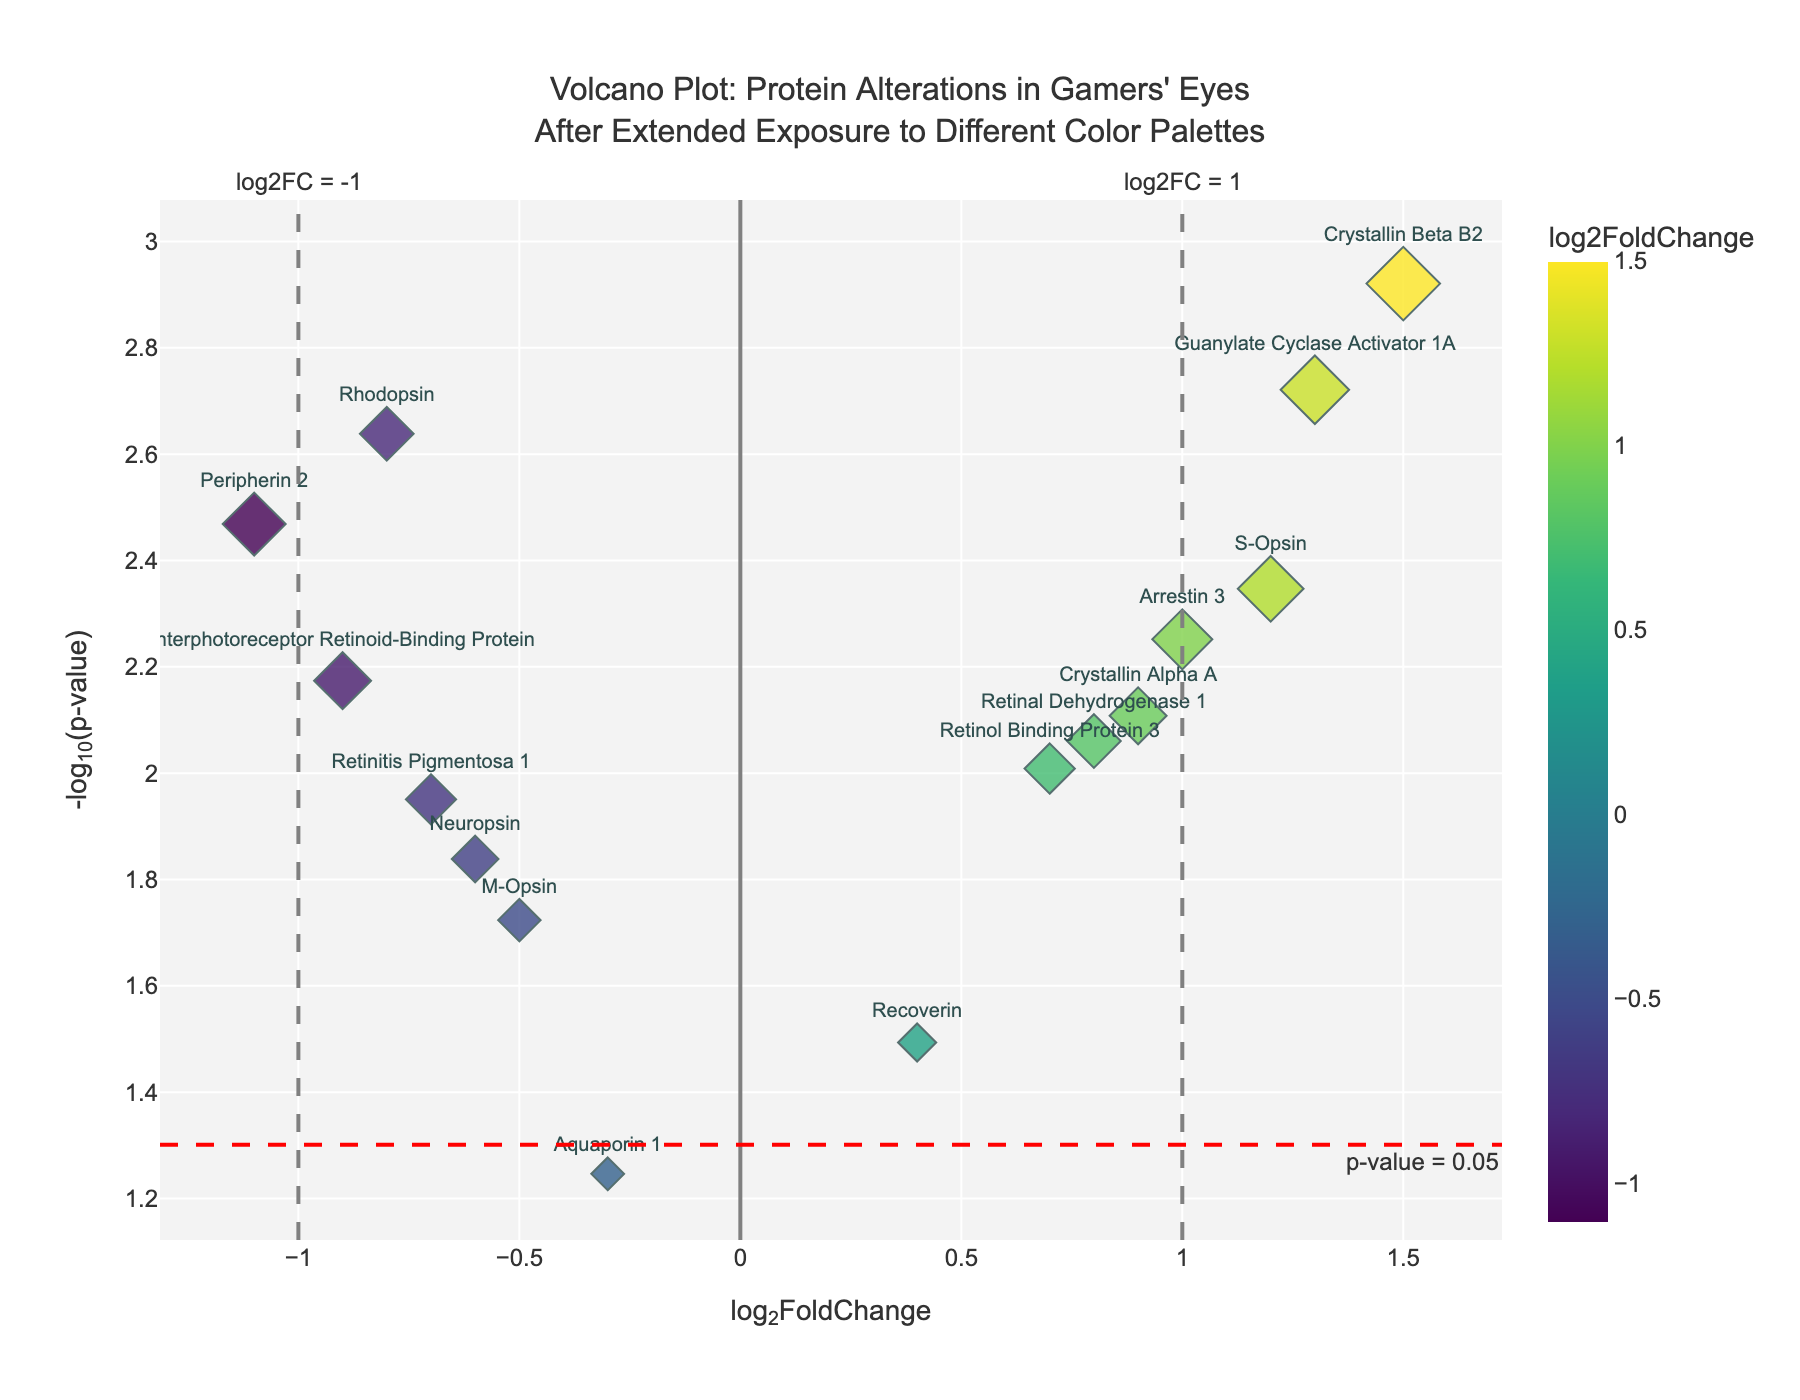Which protein has the highest -log10(pvalue)? The -log10(pvalue) is represented on the y-axis, and the highest point on this axis corresponds to Crystallin Beta B2.
Answer: Crystallin Beta B2 How many proteins have a significant alteration (p-value < 0.05)? Significant proteins can be identified by points above the red horizontal line marking the threshold of -log10(0.05). Counting these points, there are 13.
Answer: 13 What is the log2FoldChange for Rhodopsin, and is it upregulated or downregulated? Rhodopsin has a log2FoldChange of -0.8, meaning it is located to the left of zero on the x-axis, indicating it is downregulated.
Answer: -0.8, downregulated Which proteins have a log2FoldChange greater than 1? Proteins with a log2FoldChange greater than 1 are S-Opsin and Guanylate Cyclase Activator 1A, both situated to the right of the vertical line x=1 on the x-axis.
Answer: S-Opsin, Guanylate Cyclase Activator 1A What is the fold change threshold for considering meaningful protein alterations? The vertical lines on the plot at x = -1 and x = 1 mark the thresholds, considering log2FoldChange values smaller than -1 or greater than 1 as significant alterations.
Answer: ±1 Which protein appears to have the least significant p-value? The least significant p-value corresponds to the point closest to the x-axis. Aquaporin 1 is the closest, having the smallest -log10(pvalue).
Answer: Aquaporin 1 How does the alteration of Peripherin 2 compare to Arrestin 3? Peripherin 2 has a log2FoldChange of -1.1 (downregulated) and a higher -log10(pvalue), while Arrestin 3 has a log2FoldChange of 1.0 (upregulated) and a slightly lower -log10(pvalue).
Answer: Peripherin 2 is more downregulated with a higher significance compared to the upregulated Arrestin 3 Which two proteins have the closest log2FoldChange values? By comparing the log2FoldChange of all proteins, Rhodopsin (-0.8) and Retinitis Pigmentosa 1 (-0.7) have the closest values.
Answer: Rhodopsin, Retinitis Pigmentosa 1 